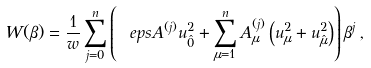<formula> <loc_0><loc_0><loc_500><loc_500>W ( \beta ) = \frac { 1 } { w } \sum _ { j = 0 } ^ { n } \left ( \ e p s A ^ { ( j ) } u _ { \hat { 0 } } ^ { 2 } + \sum _ { \mu = 1 } ^ { n } A ^ { ( j ) } _ { \mu } \left ( u _ { \mu } ^ { 2 } + u _ { \hat { \mu } } ^ { 2 } \right ) \right ) \beta ^ { j } \, ,</formula> 